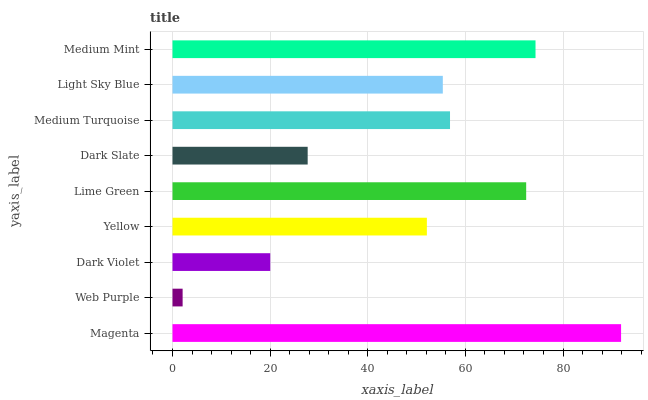Is Web Purple the minimum?
Answer yes or no. Yes. Is Magenta the maximum?
Answer yes or no. Yes. Is Dark Violet the minimum?
Answer yes or no. No. Is Dark Violet the maximum?
Answer yes or no. No. Is Dark Violet greater than Web Purple?
Answer yes or no. Yes. Is Web Purple less than Dark Violet?
Answer yes or no. Yes. Is Web Purple greater than Dark Violet?
Answer yes or no. No. Is Dark Violet less than Web Purple?
Answer yes or no. No. Is Light Sky Blue the high median?
Answer yes or no. Yes. Is Light Sky Blue the low median?
Answer yes or no. Yes. Is Yellow the high median?
Answer yes or no. No. Is Dark Slate the low median?
Answer yes or no. No. 